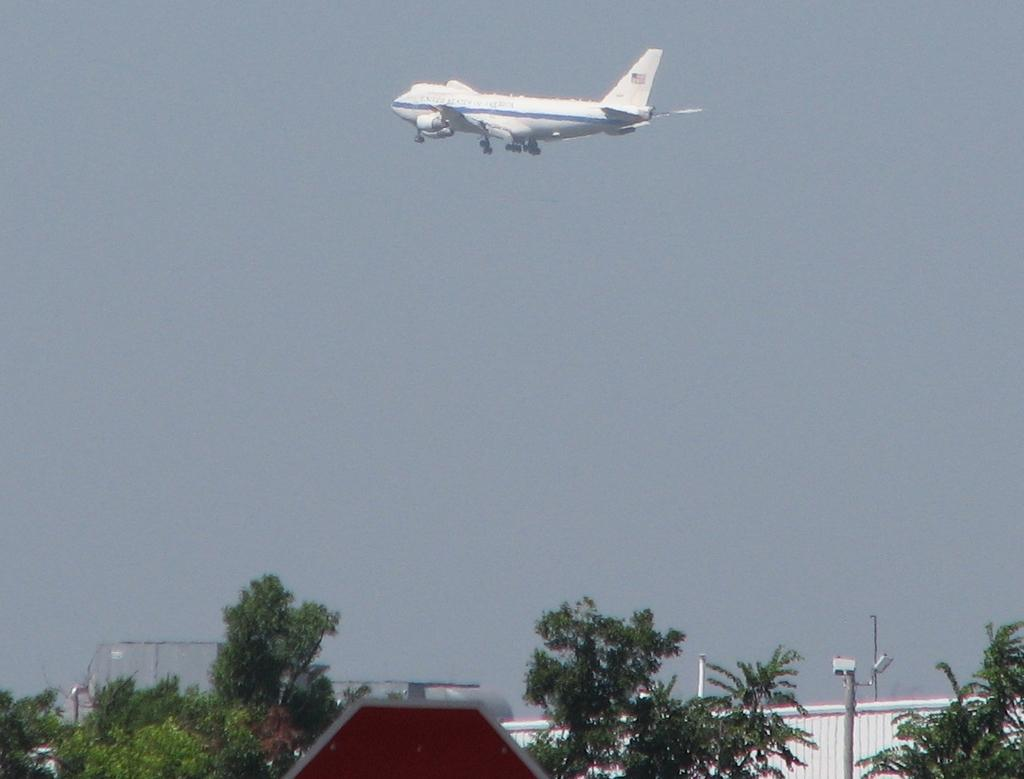What is the main subject of the image? The main subject of the image is an airplane. What is the airplane doing in the image? The airplane is flying in the air. What type of natural vegetation can be seen in the image? There are trees in the image. What man-made objects can be seen in the image? There are poles and other objects in the image. What is visible in the background of the image? The sky is visible in the background of the image. What type of religious symbol can be seen on the airplane in the image? There is no religious symbol present on the airplane in the image. What type of collar is visible on the trees in the image? There are no collars present on the trees in the image; they are natural vegetation. 